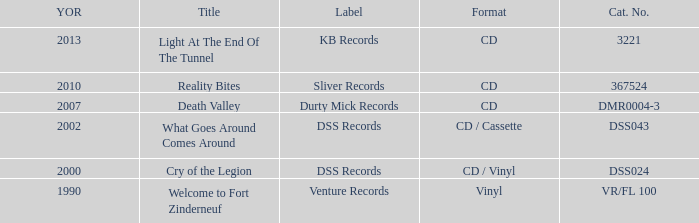What is the total year of release of the title what goes around comes around? 1.0. 